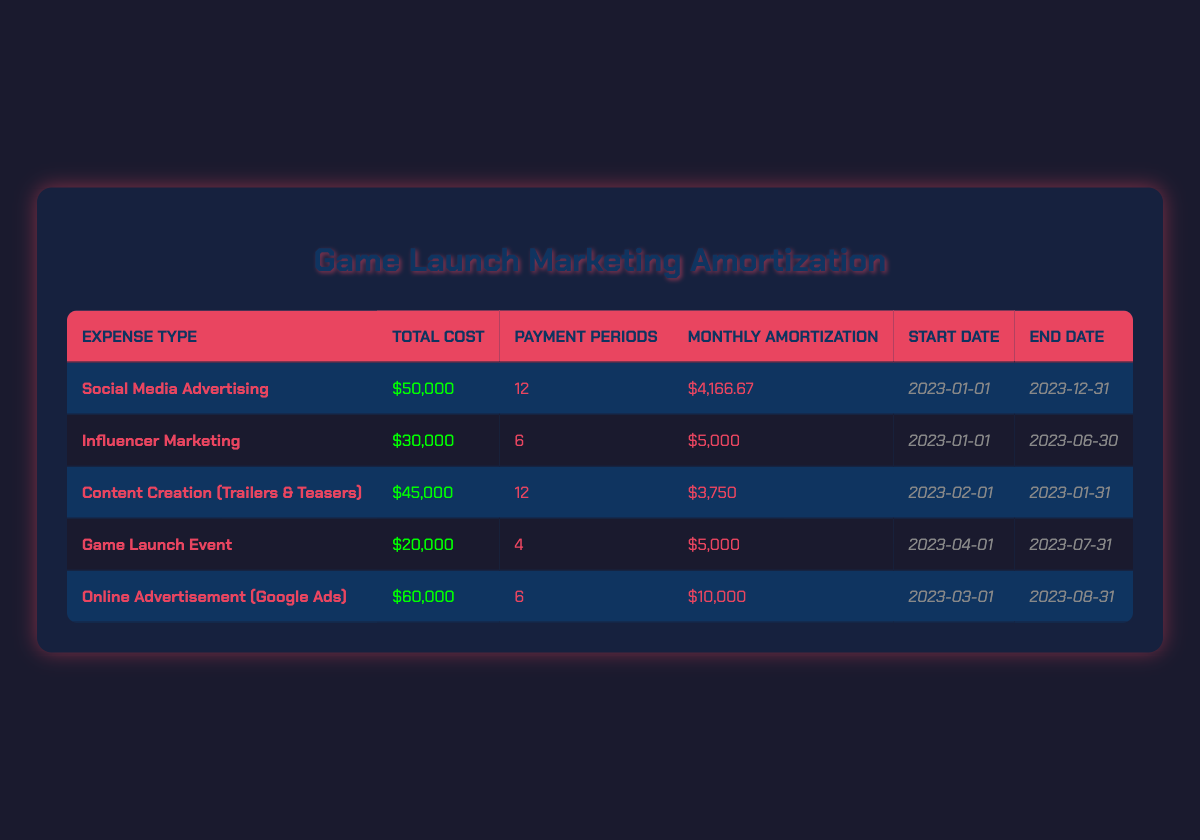What is the total cost of Social Media Advertising? The table shows that the total cost for Social Media Advertising is $50,000.
Answer: $50,000 How many payment periods are there for Influencer Marketing? The table indicates that Influencer Marketing has 6 payment periods.
Answer: 6 What is the monthly amortization for Content Creation (Trailers & Teasers)? According to the table, the monthly amortization for Content Creation is $3,750.
Answer: $3,750 Which expense type has the highest total cost? By comparing the total costs in the table, Online Advertisement (Google Ads) has the highest total cost at $60,000.
Answer: Online Advertisement (Google Ads) Is the Game Launch Event expected to be fully paid off before the end of the year? The Game Launch Event has a payment period that ends on 2023-07-31, which is before the end of the year, so yes, it will be fully paid off.
Answer: Yes What is the average monthly amortization of all the listed expenses? To find the average, sum all monthly amortizations ($4,166.67 + $5,000 + $3,750 + $5,000 + $10,000 = $27,916.67) and divide by the number of expenses (5): $27,916.67 / 5 = $5,583.33.
Answer: $5,583.33 How many expenses have a total cost of $40,000 or more? By examining the total costs, the following expenses are $40,000 or more: Social Media Advertising ($50,000), Content Creation ($45,000), and Online Advertisement ($60,000). Thus, there are 3 expenses in total.
Answer: 3 Is there an expense that started in January 2023 and ended in June 2023? The Influencer Marketing expense started on 2023-01-01 and ended on 2023-06-30, so the statement is true.
Answer: Yes What is the total amount to be amortized for all expenses combined? The total amount can be calculated by adding the total costs of all expenses ($50,000 + $30,000 + $45,000 + $20,000 + $60,000 = $205,000).
Answer: $205,000 